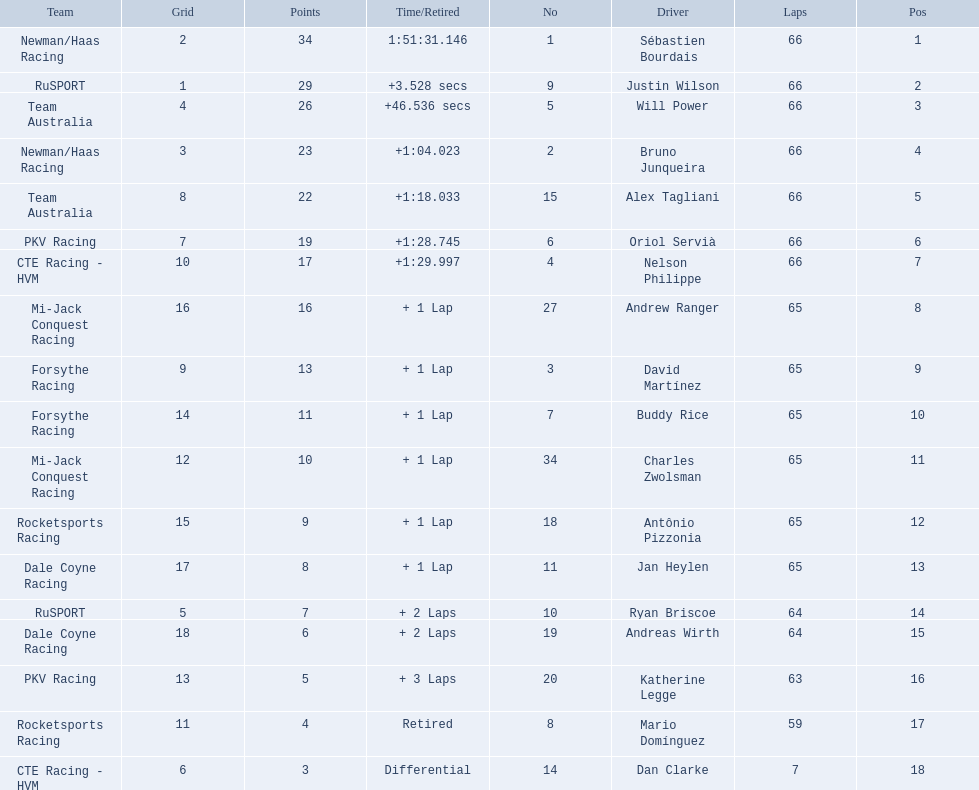Which teams participated in the 2006 gran premio telmex? Newman/Haas Racing, RuSPORT, Team Australia, Newman/Haas Racing, Team Australia, PKV Racing, CTE Racing - HVM, Mi-Jack Conquest Racing, Forsythe Racing, Forsythe Racing, Mi-Jack Conquest Racing, Rocketsports Racing, Dale Coyne Racing, RuSPORT, Dale Coyne Racing, PKV Racing, Rocketsports Racing, CTE Racing - HVM. Who were the drivers of these teams? Sébastien Bourdais, Justin Wilson, Will Power, Bruno Junqueira, Alex Tagliani, Oriol Servià, Nelson Philippe, Andrew Ranger, David Martínez, Buddy Rice, Charles Zwolsman, Antônio Pizzonia, Jan Heylen, Ryan Briscoe, Andreas Wirth, Katherine Legge, Mario Domínguez, Dan Clarke. Which driver finished last? Dan Clarke. 